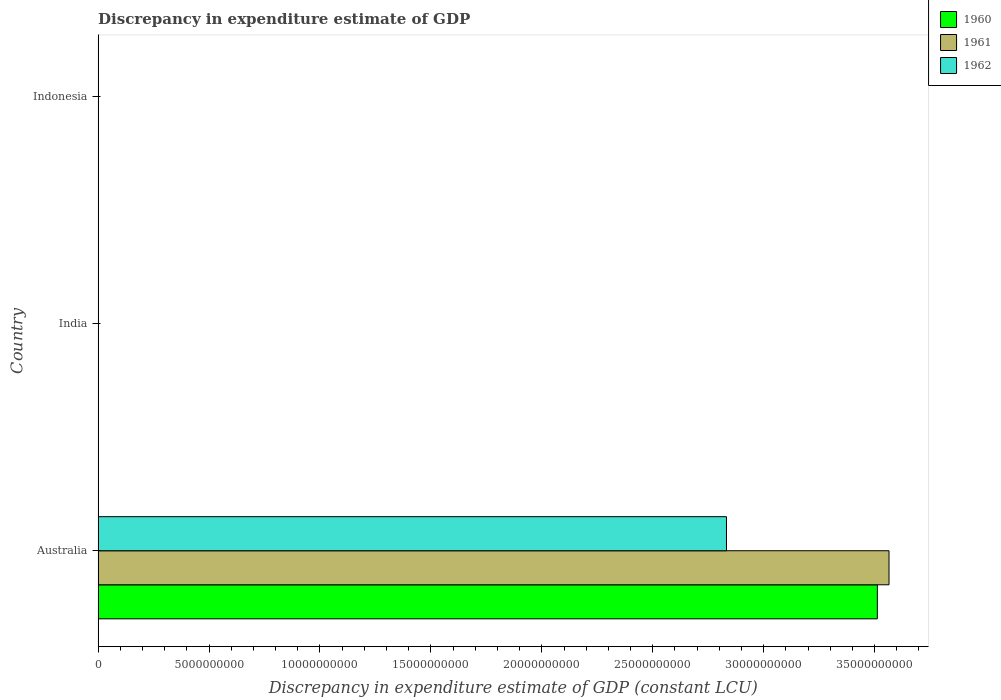How many different coloured bars are there?
Provide a short and direct response. 3. Are the number of bars per tick equal to the number of legend labels?
Provide a succinct answer. No. Are the number of bars on each tick of the Y-axis equal?
Your response must be concise. No. What is the label of the 3rd group of bars from the top?
Ensure brevity in your answer.  Australia. Across all countries, what is the maximum discrepancy in expenditure estimate of GDP in 1962?
Provide a succinct answer. 2.83e+1. Across all countries, what is the minimum discrepancy in expenditure estimate of GDP in 1961?
Offer a terse response. 0. What is the total discrepancy in expenditure estimate of GDP in 1962 in the graph?
Make the answer very short. 2.83e+1. What is the average discrepancy in expenditure estimate of GDP in 1960 per country?
Provide a succinct answer. 1.17e+1. In how many countries, is the discrepancy in expenditure estimate of GDP in 1960 greater than 4000000000 LCU?
Ensure brevity in your answer.  1. What is the difference between the highest and the lowest discrepancy in expenditure estimate of GDP in 1961?
Ensure brevity in your answer.  3.56e+1. How many countries are there in the graph?
Keep it short and to the point. 3. Does the graph contain any zero values?
Give a very brief answer. Yes. Does the graph contain grids?
Make the answer very short. No. How many legend labels are there?
Keep it short and to the point. 3. What is the title of the graph?
Your answer should be very brief. Discrepancy in expenditure estimate of GDP. What is the label or title of the X-axis?
Offer a terse response. Discrepancy in expenditure estimate of GDP (constant LCU). What is the Discrepancy in expenditure estimate of GDP (constant LCU) of 1960 in Australia?
Ensure brevity in your answer.  3.51e+1. What is the Discrepancy in expenditure estimate of GDP (constant LCU) in 1961 in Australia?
Keep it short and to the point. 3.56e+1. What is the Discrepancy in expenditure estimate of GDP (constant LCU) of 1962 in Australia?
Offer a terse response. 2.83e+1. What is the Discrepancy in expenditure estimate of GDP (constant LCU) of 1961 in India?
Your answer should be compact. 0. What is the Discrepancy in expenditure estimate of GDP (constant LCU) in 1960 in Indonesia?
Provide a short and direct response. 0. What is the Discrepancy in expenditure estimate of GDP (constant LCU) of 1961 in Indonesia?
Offer a terse response. 0. Across all countries, what is the maximum Discrepancy in expenditure estimate of GDP (constant LCU) of 1960?
Your answer should be very brief. 3.51e+1. Across all countries, what is the maximum Discrepancy in expenditure estimate of GDP (constant LCU) of 1961?
Your answer should be compact. 3.56e+1. Across all countries, what is the maximum Discrepancy in expenditure estimate of GDP (constant LCU) of 1962?
Give a very brief answer. 2.83e+1. Across all countries, what is the minimum Discrepancy in expenditure estimate of GDP (constant LCU) of 1962?
Provide a succinct answer. 0. What is the total Discrepancy in expenditure estimate of GDP (constant LCU) in 1960 in the graph?
Offer a terse response. 3.51e+1. What is the total Discrepancy in expenditure estimate of GDP (constant LCU) of 1961 in the graph?
Give a very brief answer. 3.56e+1. What is the total Discrepancy in expenditure estimate of GDP (constant LCU) of 1962 in the graph?
Your response must be concise. 2.83e+1. What is the average Discrepancy in expenditure estimate of GDP (constant LCU) in 1960 per country?
Ensure brevity in your answer.  1.17e+1. What is the average Discrepancy in expenditure estimate of GDP (constant LCU) of 1961 per country?
Make the answer very short. 1.19e+1. What is the average Discrepancy in expenditure estimate of GDP (constant LCU) in 1962 per country?
Make the answer very short. 9.44e+09. What is the difference between the Discrepancy in expenditure estimate of GDP (constant LCU) in 1960 and Discrepancy in expenditure estimate of GDP (constant LCU) in 1961 in Australia?
Provide a succinct answer. -5.25e+08. What is the difference between the Discrepancy in expenditure estimate of GDP (constant LCU) of 1960 and Discrepancy in expenditure estimate of GDP (constant LCU) of 1962 in Australia?
Offer a terse response. 6.80e+09. What is the difference between the Discrepancy in expenditure estimate of GDP (constant LCU) of 1961 and Discrepancy in expenditure estimate of GDP (constant LCU) of 1962 in Australia?
Offer a terse response. 7.33e+09. What is the difference between the highest and the lowest Discrepancy in expenditure estimate of GDP (constant LCU) in 1960?
Offer a terse response. 3.51e+1. What is the difference between the highest and the lowest Discrepancy in expenditure estimate of GDP (constant LCU) of 1961?
Ensure brevity in your answer.  3.56e+1. What is the difference between the highest and the lowest Discrepancy in expenditure estimate of GDP (constant LCU) of 1962?
Ensure brevity in your answer.  2.83e+1. 